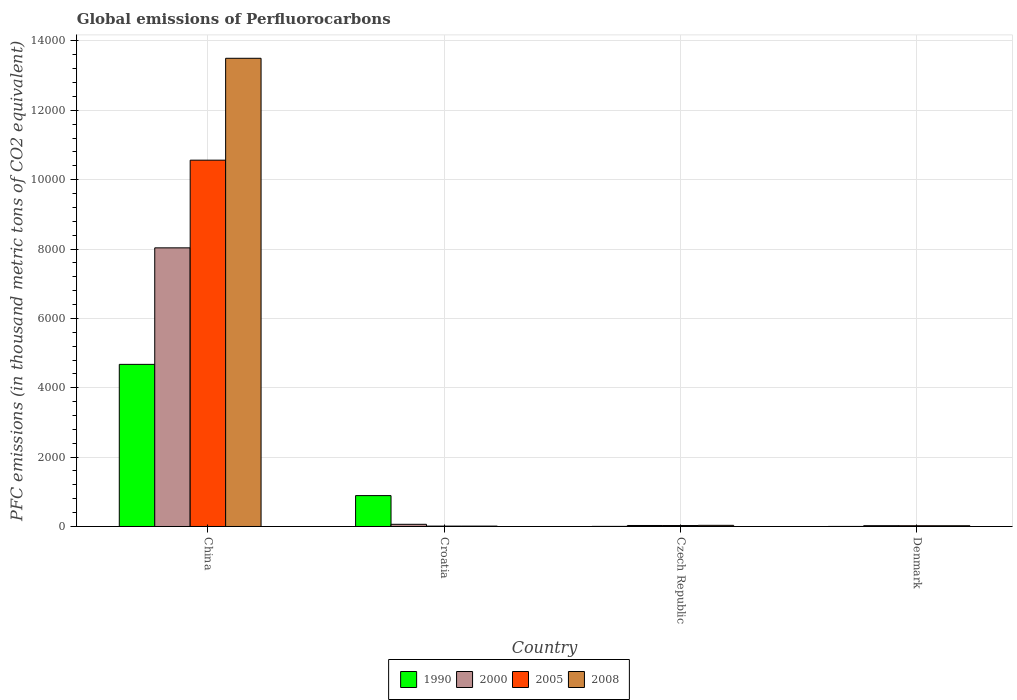How many different coloured bars are there?
Ensure brevity in your answer.  4. How many groups of bars are there?
Your answer should be very brief. 4. Are the number of bars per tick equal to the number of legend labels?
Your answer should be very brief. Yes. How many bars are there on the 2nd tick from the left?
Provide a succinct answer. 4. In how many cases, is the number of bars for a given country not equal to the number of legend labels?
Give a very brief answer. 0. Across all countries, what is the maximum global emissions of Perfluorocarbons in 2005?
Ensure brevity in your answer.  1.06e+04. Across all countries, what is the minimum global emissions of Perfluorocarbons in 1990?
Your answer should be very brief. 1.4. In which country was the global emissions of Perfluorocarbons in 2008 maximum?
Keep it short and to the point. China. What is the total global emissions of Perfluorocarbons in 2008 in the graph?
Offer a terse response. 1.36e+04. What is the difference between the global emissions of Perfluorocarbons in 2008 in Czech Republic and that in Denmark?
Offer a terse response. 11.9. What is the difference between the global emissions of Perfluorocarbons in 2005 in Croatia and the global emissions of Perfluorocarbons in 2008 in China?
Provide a succinct answer. -1.35e+04. What is the average global emissions of Perfluorocarbons in 2000 per country?
Your response must be concise. 2037.4. In how many countries, is the global emissions of Perfluorocarbons in 2008 greater than 11200 thousand metric tons?
Provide a short and direct response. 1. What is the ratio of the global emissions of Perfluorocarbons in 2000 in China to that in Czech Republic?
Offer a terse response. 278.97. Is the global emissions of Perfluorocarbons in 2008 in China less than that in Denmark?
Provide a short and direct response. No. Is the difference between the global emissions of Perfluorocarbons in 1990 in China and Czech Republic greater than the difference between the global emissions of Perfluorocarbons in 2008 in China and Czech Republic?
Ensure brevity in your answer.  No. What is the difference between the highest and the second highest global emissions of Perfluorocarbons in 2005?
Make the answer very short. 1.05e+04. What is the difference between the highest and the lowest global emissions of Perfluorocarbons in 2008?
Offer a terse response. 1.35e+04. In how many countries, is the global emissions of Perfluorocarbons in 2008 greater than the average global emissions of Perfluorocarbons in 2008 taken over all countries?
Your answer should be compact. 1. Is the sum of the global emissions of Perfluorocarbons in 2000 in Croatia and Denmark greater than the maximum global emissions of Perfluorocarbons in 1990 across all countries?
Offer a terse response. No. What does the 3rd bar from the right in Denmark represents?
Offer a terse response. 2000. Are all the bars in the graph horizontal?
Give a very brief answer. No. How many countries are there in the graph?
Your response must be concise. 4. Does the graph contain grids?
Keep it short and to the point. Yes. How many legend labels are there?
Offer a terse response. 4. What is the title of the graph?
Offer a very short reply. Global emissions of Perfluorocarbons. What is the label or title of the Y-axis?
Provide a short and direct response. PFC emissions (in thousand metric tons of CO2 equivalent). What is the PFC emissions (in thousand metric tons of CO2 equivalent) in 1990 in China?
Your response must be concise. 4674.5. What is the PFC emissions (in thousand metric tons of CO2 equivalent) of 2000 in China?
Keep it short and to the point. 8034.4. What is the PFC emissions (in thousand metric tons of CO2 equivalent) in 2005 in China?
Offer a terse response. 1.06e+04. What is the PFC emissions (in thousand metric tons of CO2 equivalent) of 2008 in China?
Offer a terse response. 1.35e+04. What is the PFC emissions (in thousand metric tons of CO2 equivalent) in 1990 in Croatia?
Offer a terse response. 890.4. What is the PFC emissions (in thousand metric tons of CO2 equivalent) in 2000 in Croatia?
Provide a short and direct response. 63. What is the PFC emissions (in thousand metric tons of CO2 equivalent) in 2005 in Croatia?
Give a very brief answer. 10.9. What is the PFC emissions (in thousand metric tons of CO2 equivalent) in 2008 in Croatia?
Make the answer very short. 11. What is the PFC emissions (in thousand metric tons of CO2 equivalent) in 1990 in Czech Republic?
Make the answer very short. 2.8. What is the PFC emissions (in thousand metric tons of CO2 equivalent) of 2000 in Czech Republic?
Provide a succinct answer. 28.8. What is the PFC emissions (in thousand metric tons of CO2 equivalent) in 2008 in Czech Republic?
Offer a terse response. 33.3. What is the PFC emissions (in thousand metric tons of CO2 equivalent) in 2000 in Denmark?
Keep it short and to the point. 23.4. What is the PFC emissions (in thousand metric tons of CO2 equivalent) in 2005 in Denmark?
Make the answer very short. 21.5. What is the PFC emissions (in thousand metric tons of CO2 equivalent) of 2008 in Denmark?
Offer a very short reply. 21.4. Across all countries, what is the maximum PFC emissions (in thousand metric tons of CO2 equivalent) in 1990?
Your response must be concise. 4674.5. Across all countries, what is the maximum PFC emissions (in thousand metric tons of CO2 equivalent) of 2000?
Offer a very short reply. 8034.4. Across all countries, what is the maximum PFC emissions (in thousand metric tons of CO2 equivalent) of 2005?
Ensure brevity in your answer.  1.06e+04. Across all countries, what is the maximum PFC emissions (in thousand metric tons of CO2 equivalent) of 2008?
Offer a terse response. 1.35e+04. Across all countries, what is the minimum PFC emissions (in thousand metric tons of CO2 equivalent) in 2000?
Offer a terse response. 23.4. Across all countries, what is the minimum PFC emissions (in thousand metric tons of CO2 equivalent) of 2008?
Your answer should be compact. 11. What is the total PFC emissions (in thousand metric tons of CO2 equivalent) in 1990 in the graph?
Give a very brief answer. 5569.1. What is the total PFC emissions (in thousand metric tons of CO2 equivalent) in 2000 in the graph?
Offer a terse response. 8149.6. What is the total PFC emissions (in thousand metric tons of CO2 equivalent) of 2005 in the graph?
Keep it short and to the point. 1.06e+04. What is the total PFC emissions (in thousand metric tons of CO2 equivalent) of 2008 in the graph?
Keep it short and to the point. 1.36e+04. What is the difference between the PFC emissions (in thousand metric tons of CO2 equivalent) of 1990 in China and that in Croatia?
Ensure brevity in your answer.  3784.1. What is the difference between the PFC emissions (in thousand metric tons of CO2 equivalent) of 2000 in China and that in Croatia?
Your answer should be compact. 7971.4. What is the difference between the PFC emissions (in thousand metric tons of CO2 equivalent) of 2005 in China and that in Croatia?
Offer a very short reply. 1.06e+04. What is the difference between the PFC emissions (in thousand metric tons of CO2 equivalent) of 2008 in China and that in Croatia?
Offer a very short reply. 1.35e+04. What is the difference between the PFC emissions (in thousand metric tons of CO2 equivalent) in 1990 in China and that in Czech Republic?
Offer a terse response. 4671.7. What is the difference between the PFC emissions (in thousand metric tons of CO2 equivalent) of 2000 in China and that in Czech Republic?
Ensure brevity in your answer.  8005.6. What is the difference between the PFC emissions (in thousand metric tons of CO2 equivalent) of 2005 in China and that in Czech Republic?
Your answer should be very brief. 1.05e+04. What is the difference between the PFC emissions (in thousand metric tons of CO2 equivalent) of 2008 in China and that in Czech Republic?
Make the answer very short. 1.35e+04. What is the difference between the PFC emissions (in thousand metric tons of CO2 equivalent) of 1990 in China and that in Denmark?
Make the answer very short. 4673.1. What is the difference between the PFC emissions (in thousand metric tons of CO2 equivalent) in 2000 in China and that in Denmark?
Make the answer very short. 8011. What is the difference between the PFC emissions (in thousand metric tons of CO2 equivalent) in 2005 in China and that in Denmark?
Your response must be concise. 1.05e+04. What is the difference between the PFC emissions (in thousand metric tons of CO2 equivalent) of 2008 in China and that in Denmark?
Keep it short and to the point. 1.35e+04. What is the difference between the PFC emissions (in thousand metric tons of CO2 equivalent) of 1990 in Croatia and that in Czech Republic?
Make the answer very short. 887.6. What is the difference between the PFC emissions (in thousand metric tons of CO2 equivalent) in 2000 in Croatia and that in Czech Republic?
Provide a short and direct response. 34.2. What is the difference between the PFC emissions (in thousand metric tons of CO2 equivalent) of 2005 in Croatia and that in Czech Republic?
Give a very brief answer. -16.6. What is the difference between the PFC emissions (in thousand metric tons of CO2 equivalent) of 2008 in Croatia and that in Czech Republic?
Offer a terse response. -22.3. What is the difference between the PFC emissions (in thousand metric tons of CO2 equivalent) in 1990 in Croatia and that in Denmark?
Keep it short and to the point. 889. What is the difference between the PFC emissions (in thousand metric tons of CO2 equivalent) of 2000 in Croatia and that in Denmark?
Provide a succinct answer. 39.6. What is the difference between the PFC emissions (in thousand metric tons of CO2 equivalent) in 2008 in Croatia and that in Denmark?
Give a very brief answer. -10.4. What is the difference between the PFC emissions (in thousand metric tons of CO2 equivalent) of 2000 in Czech Republic and that in Denmark?
Your response must be concise. 5.4. What is the difference between the PFC emissions (in thousand metric tons of CO2 equivalent) in 2008 in Czech Republic and that in Denmark?
Make the answer very short. 11.9. What is the difference between the PFC emissions (in thousand metric tons of CO2 equivalent) in 1990 in China and the PFC emissions (in thousand metric tons of CO2 equivalent) in 2000 in Croatia?
Ensure brevity in your answer.  4611.5. What is the difference between the PFC emissions (in thousand metric tons of CO2 equivalent) in 1990 in China and the PFC emissions (in thousand metric tons of CO2 equivalent) in 2005 in Croatia?
Your response must be concise. 4663.6. What is the difference between the PFC emissions (in thousand metric tons of CO2 equivalent) of 1990 in China and the PFC emissions (in thousand metric tons of CO2 equivalent) of 2008 in Croatia?
Keep it short and to the point. 4663.5. What is the difference between the PFC emissions (in thousand metric tons of CO2 equivalent) in 2000 in China and the PFC emissions (in thousand metric tons of CO2 equivalent) in 2005 in Croatia?
Make the answer very short. 8023.5. What is the difference between the PFC emissions (in thousand metric tons of CO2 equivalent) of 2000 in China and the PFC emissions (in thousand metric tons of CO2 equivalent) of 2008 in Croatia?
Your response must be concise. 8023.4. What is the difference between the PFC emissions (in thousand metric tons of CO2 equivalent) of 2005 in China and the PFC emissions (in thousand metric tons of CO2 equivalent) of 2008 in Croatia?
Make the answer very short. 1.06e+04. What is the difference between the PFC emissions (in thousand metric tons of CO2 equivalent) of 1990 in China and the PFC emissions (in thousand metric tons of CO2 equivalent) of 2000 in Czech Republic?
Make the answer very short. 4645.7. What is the difference between the PFC emissions (in thousand metric tons of CO2 equivalent) in 1990 in China and the PFC emissions (in thousand metric tons of CO2 equivalent) in 2005 in Czech Republic?
Keep it short and to the point. 4647. What is the difference between the PFC emissions (in thousand metric tons of CO2 equivalent) of 1990 in China and the PFC emissions (in thousand metric tons of CO2 equivalent) of 2008 in Czech Republic?
Make the answer very short. 4641.2. What is the difference between the PFC emissions (in thousand metric tons of CO2 equivalent) in 2000 in China and the PFC emissions (in thousand metric tons of CO2 equivalent) in 2005 in Czech Republic?
Your response must be concise. 8006.9. What is the difference between the PFC emissions (in thousand metric tons of CO2 equivalent) in 2000 in China and the PFC emissions (in thousand metric tons of CO2 equivalent) in 2008 in Czech Republic?
Your answer should be compact. 8001.1. What is the difference between the PFC emissions (in thousand metric tons of CO2 equivalent) of 2005 in China and the PFC emissions (in thousand metric tons of CO2 equivalent) of 2008 in Czech Republic?
Provide a succinct answer. 1.05e+04. What is the difference between the PFC emissions (in thousand metric tons of CO2 equivalent) in 1990 in China and the PFC emissions (in thousand metric tons of CO2 equivalent) in 2000 in Denmark?
Provide a succinct answer. 4651.1. What is the difference between the PFC emissions (in thousand metric tons of CO2 equivalent) of 1990 in China and the PFC emissions (in thousand metric tons of CO2 equivalent) of 2005 in Denmark?
Offer a terse response. 4653. What is the difference between the PFC emissions (in thousand metric tons of CO2 equivalent) of 1990 in China and the PFC emissions (in thousand metric tons of CO2 equivalent) of 2008 in Denmark?
Offer a terse response. 4653.1. What is the difference between the PFC emissions (in thousand metric tons of CO2 equivalent) of 2000 in China and the PFC emissions (in thousand metric tons of CO2 equivalent) of 2005 in Denmark?
Ensure brevity in your answer.  8012.9. What is the difference between the PFC emissions (in thousand metric tons of CO2 equivalent) of 2000 in China and the PFC emissions (in thousand metric tons of CO2 equivalent) of 2008 in Denmark?
Your answer should be very brief. 8013. What is the difference between the PFC emissions (in thousand metric tons of CO2 equivalent) in 2005 in China and the PFC emissions (in thousand metric tons of CO2 equivalent) in 2008 in Denmark?
Keep it short and to the point. 1.05e+04. What is the difference between the PFC emissions (in thousand metric tons of CO2 equivalent) in 1990 in Croatia and the PFC emissions (in thousand metric tons of CO2 equivalent) in 2000 in Czech Republic?
Your answer should be compact. 861.6. What is the difference between the PFC emissions (in thousand metric tons of CO2 equivalent) of 1990 in Croatia and the PFC emissions (in thousand metric tons of CO2 equivalent) of 2005 in Czech Republic?
Your response must be concise. 862.9. What is the difference between the PFC emissions (in thousand metric tons of CO2 equivalent) of 1990 in Croatia and the PFC emissions (in thousand metric tons of CO2 equivalent) of 2008 in Czech Republic?
Ensure brevity in your answer.  857.1. What is the difference between the PFC emissions (in thousand metric tons of CO2 equivalent) of 2000 in Croatia and the PFC emissions (in thousand metric tons of CO2 equivalent) of 2005 in Czech Republic?
Give a very brief answer. 35.5. What is the difference between the PFC emissions (in thousand metric tons of CO2 equivalent) in 2000 in Croatia and the PFC emissions (in thousand metric tons of CO2 equivalent) in 2008 in Czech Republic?
Your response must be concise. 29.7. What is the difference between the PFC emissions (in thousand metric tons of CO2 equivalent) of 2005 in Croatia and the PFC emissions (in thousand metric tons of CO2 equivalent) of 2008 in Czech Republic?
Your response must be concise. -22.4. What is the difference between the PFC emissions (in thousand metric tons of CO2 equivalent) of 1990 in Croatia and the PFC emissions (in thousand metric tons of CO2 equivalent) of 2000 in Denmark?
Your response must be concise. 867. What is the difference between the PFC emissions (in thousand metric tons of CO2 equivalent) of 1990 in Croatia and the PFC emissions (in thousand metric tons of CO2 equivalent) of 2005 in Denmark?
Your answer should be compact. 868.9. What is the difference between the PFC emissions (in thousand metric tons of CO2 equivalent) in 1990 in Croatia and the PFC emissions (in thousand metric tons of CO2 equivalent) in 2008 in Denmark?
Provide a short and direct response. 869. What is the difference between the PFC emissions (in thousand metric tons of CO2 equivalent) of 2000 in Croatia and the PFC emissions (in thousand metric tons of CO2 equivalent) of 2005 in Denmark?
Provide a succinct answer. 41.5. What is the difference between the PFC emissions (in thousand metric tons of CO2 equivalent) of 2000 in Croatia and the PFC emissions (in thousand metric tons of CO2 equivalent) of 2008 in Denmark?
Give a very brief answer. 41.6. What is the difference between the PFC emissions (in thousand metric tons of CO2 equivalent) in 1990 in Czech Republic and the PFC emissions (in thousand metric tons of CO2 equivalent) in 2000 in Denmark?
Your response must be concise. -20.6. What is the difference between the PFC emissions (in thousand metric tons of CO2 equivalent) of 1990 in Czech Republic and the PFC emissions (in thousand metric tons of CO2 equivalent) of 2005 in Denmark?
Give a very brief answer. -18.7. What is the difference between the PFC emissions (in thousand metric tons of CO2 equivalent) in 1990 in Czech Republic and the PFC emissions (in thousand metric tons of CO2 equivalent) in 2008 in Denmark?
Your answer should be very brief. -18.6. What is the difference between the PFC emissions (in thousand metric tons of CO2 equivalent) in 2000 in Czech Republic and the PFC emissions (in thousand metric tons of CO2 equivalent) in 2005 in Denmark?
Offer a very short reply. 7.3. What is the difference between the PFC emissions (in thousand metric tons of CO2 equivalent) in 2005 in Czech Republic and the PFC emissions (in thousand metric tons of CO2 equivalent) in 2008 in Denmark?
Make the answer very short. 6.1. What is the average PFC emissions (in thousand metric tons of CO2 equivalent) in 1990 per country?
Offer a very short reply. 1392.28. What is the average PFC emissions (in thousand metric tons of CO2 equivalent) in 2000 per country?
Your answer should be compact. 2037.4. What is the average PFC emissions (in thousand metric tons of CO2 equivalent) in 2005 per country?
Your answer should be compact. 2655.68. What is the average PFC emissions (in thousand metric tons of CO2 equivalent) in 2008 per country?
Your answer should be compact. 3391.57. What is the difference between the PFC emissions (in thousand metric tons of CO2 equivalent) in 1990 and PFC emissions (in thousand metric tons of CO2 equivalent) in 2000 in China?
Provide a succinct answer. -3359.9. What is the difference between the PFC emissions (in thousand metric tons of CO2 equivalent) in 1990 and PFC emissions (in thousand metric tons of CO2 equivalent) in 2005 in China?
Your response must be concise. -5888.3. What is the difference between the PFC emissions (in thousand metric tons of CO2 equivalent) of 1990 and PFC emissions (in thousand metric tons of CO2 equivalent) of 2008 in China?
Give a very brief answer. -8826.1. What is the difference between the PFC emissions (in thousand metric tons of CO2 equivalent) of 2000 and PFC emissions (in thousand metric tons of CO2 equivalent) of 2005 in China?
Offer a terse response. -2528.4. What is the difference between the PFC emissions (in thousand metric tons of CO2 equivalent) of 2000 and PFC emissions (in thousand metric tons of CO2 equivalent) of 2008 in China?
Your answer should be compact. -5466.2. What is the difference between the PFC emissions (in thousand metric tons of CO2 equivalent) of 2005 and PFC emissions (in thousand metric tons of CO2 equivalent) of 2008 in China?
Keep it short and to the point. -2937.8. What is the difference between the PFC emissions (in thousand metric tons of CO2 equivalent) of 1990 and PFC emissions (in thousand metric tons of CO2 equivalent) of 2000 in Croatia?
Provide a short and direct response. 827.4. What is the difference between the PFC emissions (in thousand metric tons of CO2 equivalent) in 1990 and PFC emissions (in thousand metric tons of CO2 equivalent) in 2005 in Croatia?
Provide a short and direct response. 879.5. What is the difference between the PFC emissions (in thousand metric tons of CO2 equivalent) of 1990 and PFC emissions (in thousand metric tons of CO2 equivalent) of 2008 in Croatia?
Your response must be concise. 879.4. What is the difference between the PFC emissions (in thousand metric tons of CO2 equivalent) in 2000 and PFC emissions (in thousand metric tons of CO2 equivalent) in 2005 in Croatia?
Provide a short and direct response. 52.1. What is the difference between the PFC emissions (in thousand metric tons of CO2 equivalent) of 2000 and PFC emissions (in thousand metric tons of CO2 equivalent) of 2008 in Croatia?
Ensure brevity in your answer.  52. What is the difference between the PFC emissions (in thousand metric tons of CO2 equivalent) in 1990 and PFC emissions (in thousand metric tons of CO2 equivalent) in 2000 in Czech Republic?
Provide a short and direct response. -26. What is the difference between the PFC emissions (in thousand metric tons of CO2 equivalent) in 1990 and PFC emissions (in thousand metric tons of CO2 equivalent) in 2005 in Czech Republic?
Keep it short and to the point. -24.7. What is the difference between the PFC emissions (in thousand metric tons of CO2 equivalent) of 1990 and PFC emissions (in thousand metric tons of CO2 equivalent) of 2008 in Czech Republic?
Your answer should be compact. -30.5. What is the difference between the PFC emissions (in thousand metric tons of CO2 equivalent) in 2000 and PFC emissions (in thousand metric tons of CO2 equivalent) in 2005 in Czech Republic?
Provide a short and direct response. 1.3. What is the difference between the PFC emissions (in thousand metric tons of CO2 equivalent) of 2005 and PFC emissions (in thousand metric tons of CO2 equivalent) of 2008 in Czech Republic?
Offer a terse response. -5.8. What is the difference between the PFC emissions (in thousand metric tons of CO2 equivalent) in 1990 and PFC emissions (in thousand metric tons of CO2 equivalent) in 2005 in Denmark?
Offer a terse response. -20.1. What is the difference between the PFC emissions (in thousand metric tons of CO2 equivalent) in 2000 and PFC emissions (in thousand metric tons of CO2 equivalent) in 2005 in Denmark?
Your answer should be compact. 1.9. What is the difference between the PFC emissions (in thousand metric tons of CO2 equivalent) in 2000 and PFC emissions (in thousand metric tons of CO2 equivalent) in 2008 in Denmark?
Your answer should be compact. 2. What is the ratio of the PFC emissions (in thousand metric tons of CO2 equivalent) in 1990 in China to that in Croatia?
Your response must be concise. 5.25. What is the ratio of the PFC emissions (in thousand metric tons of CO2 equivalent) of 2000 in China to that in Croatia?
Ensure brevity in your answer.  127.53. What is the ratio of the PFC emissions (in thousand metric tons of CO2 equivalent) of 2005 in China to that in Croatia?
Make the answer very short. 969.06. What is the ratio of the PFC emissions (in thousand metric tons of CO2 equivalent) in 2008 in China to that in Croatia?
Provide a succinct answer. 1227.33. What is the ratio of the PFC emissions (in thousand metric tons of CO2 equivalent) of 1990 in China to that in Czech Republic?
Provide a succinct answer. 1669.46. What is the ratio of the PFC emissions (in thousand metric tons of CO2 equivalent) of 2000 in China to that in Czech Republic?
Keep it short and to the point. 278.97. What is the ratio of the PFC emissions (in thousand metric tons of CO2 equivalent) in 2005 in China to that in Czech Republic?
Keep it short and to the point. 384.1. What is the ratio of the PFC emissions (in thousand metric tons of CO2 equivalent) in 2008 in China to that in Czech Republic?
Your response must be concise. 405.42. What is the ratio of the PFC emissions (in thousand metric tons of CO2 equivalent) in 1990 in China to that in Denmark?
Provide a succinct answer. 3338.93. What is the ratio of the PFC emissions (in thousand metric tons of CO2 equivalent) of 2000 in China to that in Denmark?
Provide a succinct answer. 343.35. What is the ratio of the PFC emissions (in thousand metric tons of CO2 equivalent) of 2005 in China to that in Denmark?
Make the answer very short. 491.29. What is the ratio of the PFC emissions (in thousand metric tons of CO2 equivalent) in 2008 in China to that in Denmark?
Your answer should be very brief. 630.87. What is the ratio of the PFC emissions (in thousand metric tons of CO2 equivalent) in 1990 in Croatia to that in Czech Republic?
Offer a terse response. 318. What is the ratio of the PFC emissions (in thousand metric tons of CO2 equivalent) of 2000 in Croatia to that in Czech Republic?
Keep it short and to the point. 2.19. What is the ratio of the PFC emissions (in thousand metric tons of CO2 equivalent) in 2005 in Croatia to that in Czech Republic?
Your answer should be very brief. 0.4. What is the ratio of the PFC emissions (in thousand metric tons of CO2 equivalent) in 2008 in Croatia to that in Czech Republic?
Offer a terse response. 0.33. What is the ratio of the PFC emissions (in thousand metric tons of CO2 equivalent) of 1990 in Croatia to that in Denmark?
Offer a very short reply. 636. What is the ratio of the PFC emissions (in thousand metric tons of CO2 equivalent) in 2000 in Croatia to that in Denmark?
Ensure brevity in your answer.  2.69. What is the ratio of the PFC emissions (in thousand metric tons of CO2 equivalent) in 2005 in Croatia to that in Denmark?
Ensure brevity in your answer.  0.51. What is the ratio of the PFC emissions (in thousand metric tons of CO2 equivalent) in 2008 in Croatia to that in Denmark?
Make the answer very short. 0.51. What is the ratio of the PFC emissions (in thousand metric tons of CO2 equivalent) of 2000 in Czech Republic to that in Denmark?
Your answer should be very brief. 1.23. What is the ratio of the PFC emissions (in thousand metric tons of CO2 equivalent) of 2005 in Czech Republic to that in Denmark?
Provide a short and direct response. 1.28. What is the ratio of the PFC emissions (in thousand metric tons of CO2 equivalent) in 2008 in Czech Republic to that in Denmark?
Give a very brief answer. 1.56. What is the difference between the highest and the second highest PFC emissions (in thousand metric tons of CO2 equivalent) in 1990?
Ensure brevity in your answer.  3784.1. What is the difference between the highest and the second highest PFC emissions (in thousand metric tons of CO2 equivalent) of 2000?
Offer a very short reply. 7971.4. What is the difference between the highest and the second highest PFC emissions (in thousand metric tons of CO2 equivalent) in 2005?
Provide a succinct answer. 1.05e+04. What is the difference between the highest and the second highest PFC emissions (in thousand metric tons of CO2 equivalent) of 2008?
Your answer should be very brief. 1.35e+04. What is the difference between the highest and the lowest PFC emissions (in thousand metric tons of CO2 equivalent) in 1990?
Keep it short and to the point. 4673.1. What is the difference between the highest and the lowest PFC emissions (in thousand metric tons of CO2 equivalent) in 2000?
Offer a very short reply. 8011. What is the difference between the highest and the lowest PFC emissions (in thousand metric tons of CO2 equivalent) in 2005?
Ensure brevity in your answer.  1.06e+04. What is the difference between the highest and the lowest PFC emissions (in thousand metric tons of CO2 equivalent) of 2008?
Your answer should be very brief. 1.35e+04. 